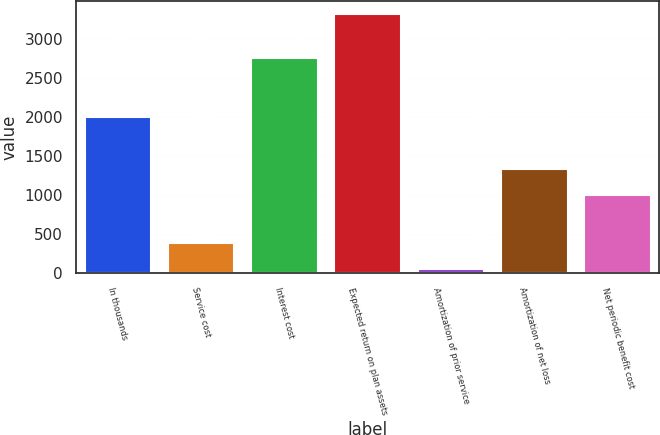Convert chart to OTSL. <chart><loc_0><loc_0><loc_500><loc_500><bar_chart><fcel>In thousands<fcel>Service cost<fcel>Interest cost<fcel>Expected return on plan assets<fcel>Amortization of prior service<fcel>Amortization of net loss<fcel>Net periodic benefit cost<nl><fcel>2008<fcel>385.6<fcel>2763<fcel>3325<fcel>59<fcel>1330.6<fcel>1004<nl></chart> 